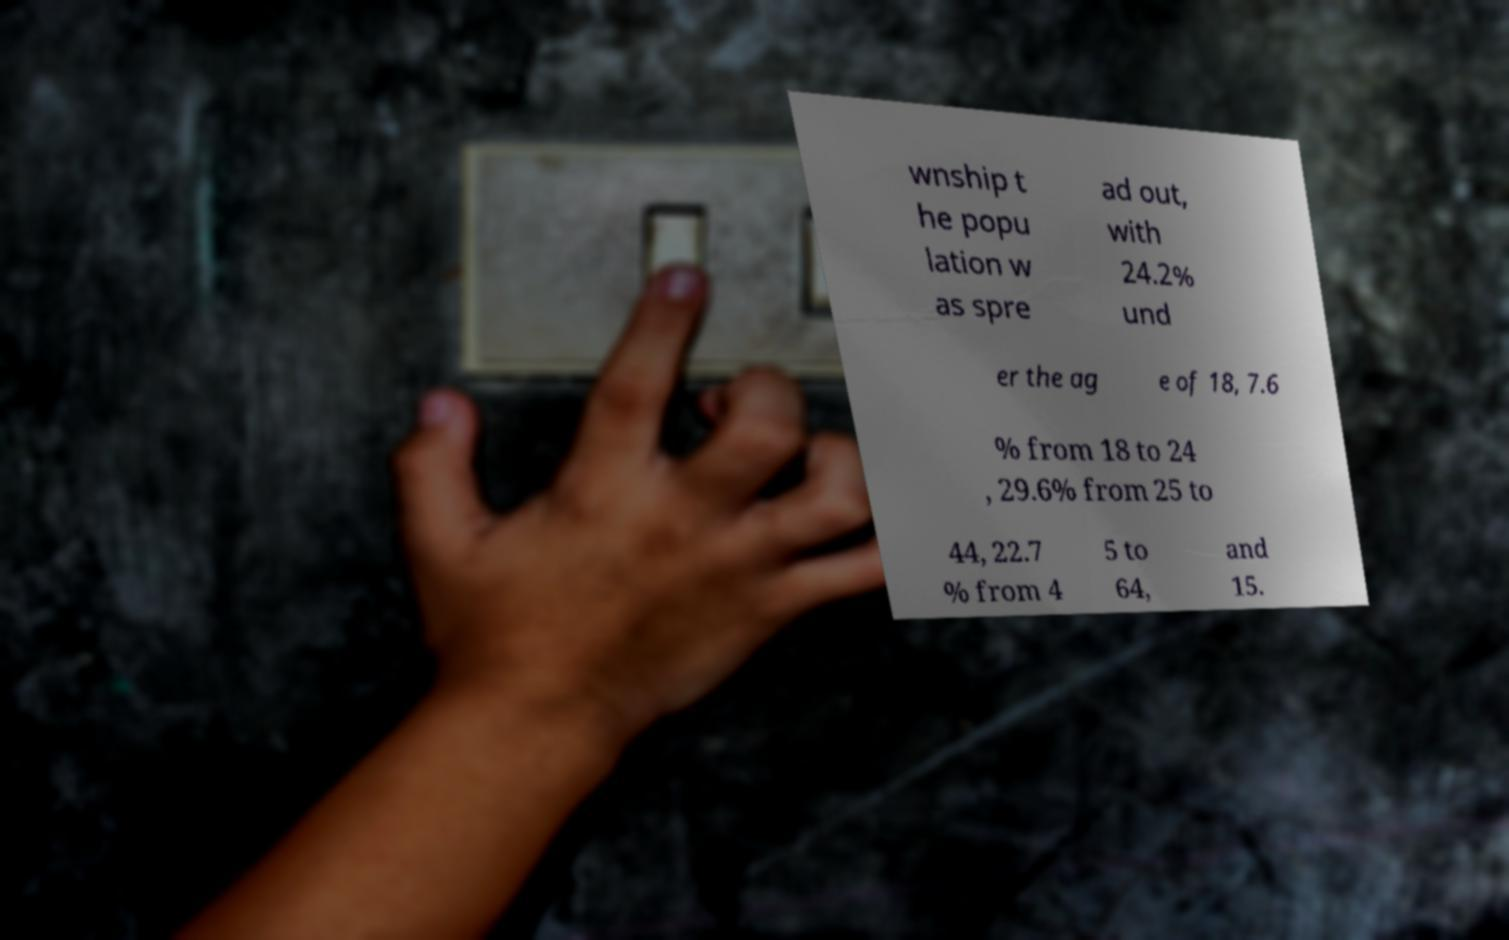There's text embedded in this image that I need extracted. Can you transcribe it verbatim? wnship t he popu lation w as spre ad out, with 24.2% und er the ag e of 18, 7.6 % from 18 to 24 , 29.6% from 25 to 44, 22.7 % from 4 5 to 64, and 15. 